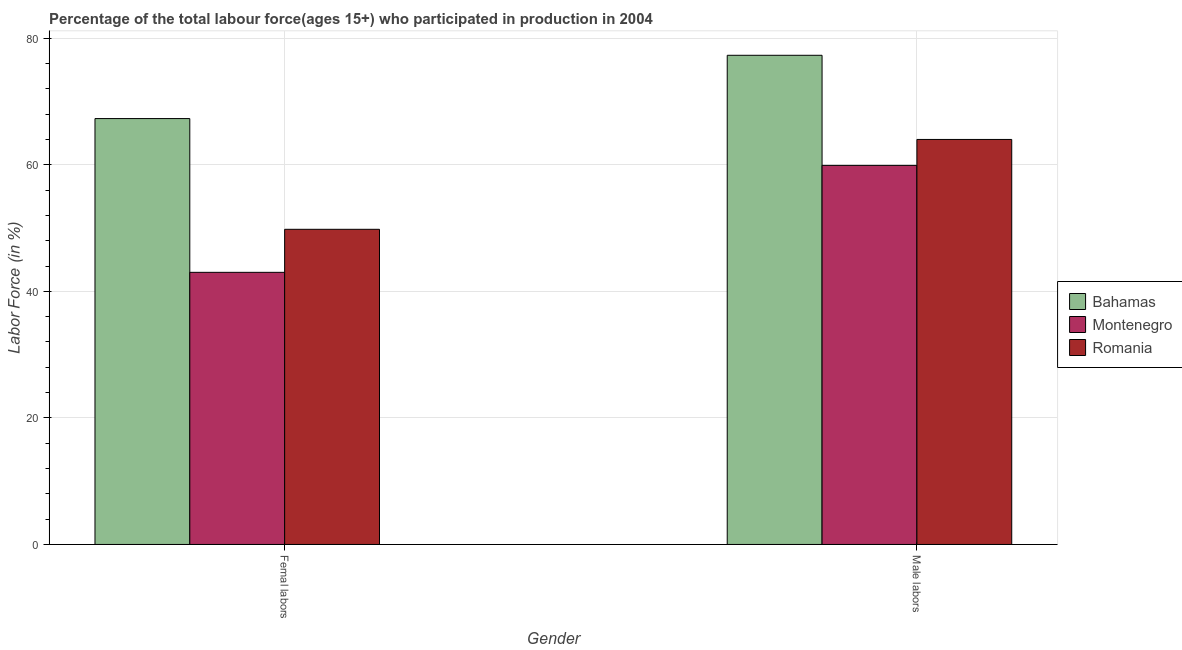How many different coloured bars are there?
Your answer should be compact. 3. Are the number of bars per tick equal to the number of legend labels?
Give a very brief answer. Yes. Are the number of bars on each tick of the X-axis equal?
Offer a terse response. Yes. How many bars are there on the 1st tick from the left?
Offer a very short reply. 3. What is the label of the 2nd group of bars from the left?
Ensure brevity in your answer.  Male labors. What is the percentage of male labour force in Bahamas?
Make the answer very short. 77.3. Across all countries, what is the maximum percentage of female labor force?
Make the answer very short. 67.3. Across all countries, what is the minimum percentage of female labor force?
Your answer should be very brief. 43. In which country was the percentage of female labor force maximum?
Give a very brief answer. Bahamas. In which country was the percentage of female labor force minimum?
Ensure brevity in your answer.  Montenegro. What is the total percentage of female labor force in the graph?
Offer a very short reply. 160.1. What is the difference between the percentage of male labour force in Bahamas and that in Montenegro?
Give a very brief answer. 17.4. What is the difference between the percentage of female labor force in Romania and the percentage of male labour force in Montenegro?
Offer a terse response. -10.1. What is the average percentage of female labor force per country?
Your answer should be very brief. 53.37. What is the difference between the percentage of female labor force and percentage of male labour force in Montenegro?
Offer a very short reply. -16.9. In how many countries, is the percentage of male labour force greater than 68 %?
Your answer should be compact. 1. What is the ratio of the percentage of female labor force in Montenegro to that in Bahamas?
Ensure brevity in your answer.  0.64. Is the percentage of female labor force in Bahamas less than that in Montenegro?
Your answer should be compact. No. In how many countries, is the percentage of female labor force greater than the average percentage of female labor force taken over all countries?
Give a very brief answer. 1. What does the 1st bar from the left in Male labors represents?
Your answer should be very brief. Bahamas. What does the 1st bar from the right in Male labors represents?
Keep it short and to the point. Romania. How many bars are there?
Keep it short and to the point. 6. What is the difference between two consecutive major ticks on the Y-axis?
Give a very brief answer. 20. Are the values on the major ticks of Y-axis written in scientific E-notation?
Offer a terse response. No. Does the graph contain grids?
Offer a very short reply. Yes. Where does the legend appear in the graph?
Your answer should be compact. Center right. How are the legend labels stacked?
Give a very brief answer. Vertical. What is the title of the graph?
Offer a terse response. Percentage of the total labour force(ages 15+) who participated in production in 2004. Does "Bermuda" appear as one of the legend labels in the graph?
Provide a short and direct response. No. What is the label or title of the Y-axis?
Make the answer very short. Labor Force (in %). What is the Labor Force (in %) of Bahamas in Femal labors?
Provide a short and direct response. 67.3. What is the Labor Force (in %) of Romania in Femal labors?
Your answer should be very brief. 49.8. What is the Labor Force (in %) of Bahamas in Male labors?
Ensure brevity in your answer.  77.3. What is the Labor Force (in %) in Montenegro in Male labors?
Offer a terse response. 59.9. Across all Gender, what is the maximum Labor Force (in %) in Bahamas?
Keep it short and to the point. 77.3. Across all Gender, what is the maximum Labor Force (in %) of Montenegro?
Offer a terse response. 59.9. Across all Gender, what is the maximum Labor Force (in %) of Romania?
Provide a short and direct response. 64. Across all Gender, what is the minimum Labor Force (in %) in Bahamas?
Provide a short and direct response. 67.3. Across all Gender, what is the minimum Labor Force (in %) in Montenegro?
Give a very brief answer. 43. Across all Gender, what is the minimum Labor Force (in %) in Romania?
Offer a terse response. 49.8. What is the total Labor Force (in %) of Bahamas in the graph?
Provide a succinct answer. 144.6. What is the total Labor Force (in %) in Montenegro in the graph?
Offer a very short reply. 102.9. What is the total Labor Force (in %) in Romania in the graph?
Give a very brief answer. 113.8. What is the difference between the Labor Force (in %) of Bahamas in Femal labors and that in Male labors?
Ensure brevity in your answer.  -10. What is the difference between the Labor Force (in %) of Montenegro in Femal labors and that in Male labors?
Offer a terse response. -16.9. What is the difference between the Labor Force (in %) of Romania in Femal labors and that in Male labors?
Your answer should be very brief. -14.2. What is the difference between the Labor Force (in %) in Bahamas in Femal labors and the Labor Force (in %) in Montenegro in Male labors?
Provide a short and direct response. 7.4. What is the difference between the Labor Force (in %) of Montenegro in Femal labors and the Labor Force (in %) of Romania in Male labors?
Provide a succinct answer. -21. What is the average Labor Force (in %) of Bahamas per Gender?
Your response must be concise. 72.3. What is the average Labor Force (in %) in Montenegro per Gender?
Offer a terse response. 51.45. What is the average Labor Force (in %) of Romania per Gender?
Ensure brevity in your answer.  56.9. What is the difference between the Labor Force (in %) in Bahamas and Labor Force (in %) in Montenegro in Femal labors?
Your response must be concise. 24.3. What is the difference between the Labor Force (in %) in Bahamas and Labor Force (in %) in Romania in Femal labors?
Your response must be concise. 17.5. What is the difference between the Labor Force (in %) of Bahamas and Labor Force (in %) of Montenegro in Male labors?
Give a very brief answer. 17.4. What is the difference between the Labor Force (in %) in Bahamas and Labor Force (in %) in Romania in Male labors?
Give a very brief answer. 13.3. What is the ratio of the Labor Force (in %) in Bahamas in Femal labors to that in Male labors?
Keep it short and to the point. 0.87. What is the ratio of the Labor Force (in %) of Montenegro in Femal labors to that in Male labors?
Offer a terse response. 0.72. What is the ratio of the Labor Force (in %) of Romania in Femal labors to that in Male labors?
Ensure brevity in your answer.  0.78. What is the difference between the highest and the second highest Labor Force (in %) of Bahamas?
Ensure brevity in your answer.  10. What is the difference between the highest and the second highest Labor Force (in %) of Montenegro?
Keep it short and to the point. 16.9. What is the difference between the highest and the lowest Labor Force (in %) of Romania?
Provide a short and direct response. 14.2. 